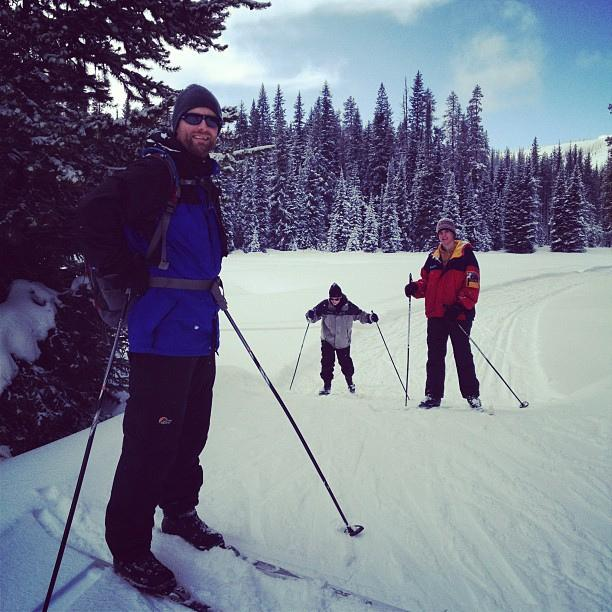Who is skiing with the man in front? Please explain your reasoning. those behind. There are companions following. 